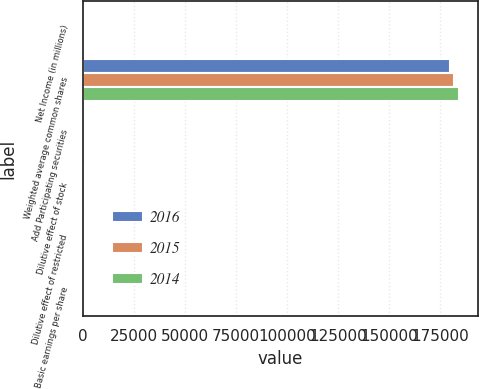Convert chart. <chart><loc_0><loc_0><loc_500><loc_500><stacked_bar_chart><ecel><fcel>Net Income (in millions)<fcel>Weighted average common shares<fcel>Add Participating securities<fcel>Dilutive effect of stock<fcel>Dilutive effect of restricted<fcel>Basic earnings per share<nl><fcel>2016<fcel>260<fcel>180038<fcel>37<fcel>499<fcel>433<fcel>1.45<nl><fcel>2015<fcel>340<fcel>181737<fcel>39<fcel>465<fcel>379<fcel>1.88<nl><fcel>2014<fcel>337<fcel>184249<fcel>47<fcel>643<fcel>529<fcel>1.84<nl></chart> 